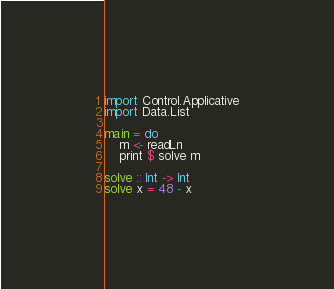<code> <loc_0><loc_0><loc_500><loc_500><_Haskell_>import Control.Applicative
import Data.List

main = do
    m <- readLn
    print $ solve m

solve :: Int -> Int
solve x = 48 - x</code> 